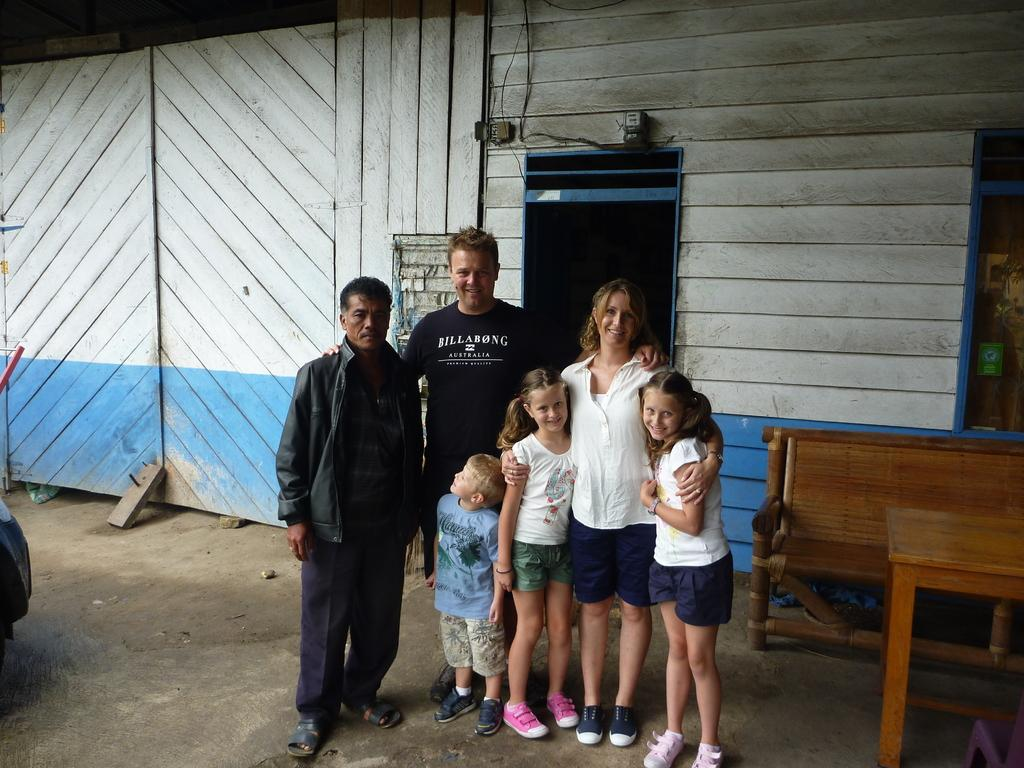How many people are present in the image? There are six persons in the image. Where are the persons standing? The persons are standing on the floor, table, and bench. What can be seen in the background of the image? There is a wooden wall in the background of the image. Can you tell if the image was taken during the day or night? The image was likely taken during the day, as there is no indication of darkness or artificial lighting. What type of wax can be seen melting on the table in the image? There is no wax present in the image; it only features six persons standing on different surfaces. How many berries are visible on the bench in the image? There are no berries present in the image; it only features six persons standing on different surfaces. 